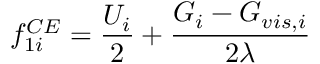<formula> <loc_0><loc_0><loc_500><loc_500>f _ { 1 i } ^ { C E } = \frac { U _ { i } } { 2 } + \frac { G _ { i } - G _ { v i s , i } } { 2 \lambda }</formula> 